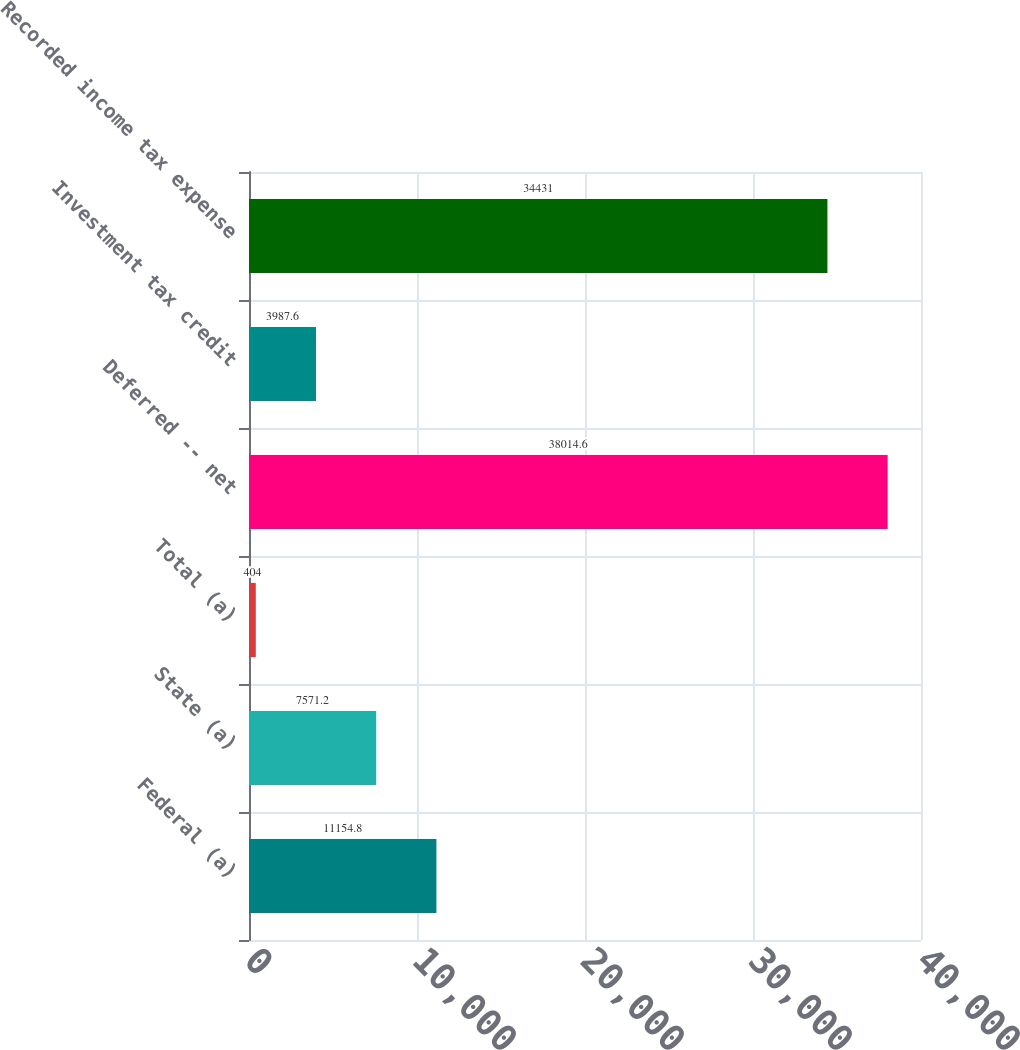<chart> <loc_0><loc_0><loc_500><loc_500><bar_chart><fcel>Federal (a)<fcel>State (a)<fcel>Total (a)<fcel>Deferred -- net<fcel>Investment tax credit<fcel>Recorded income tax expense<nl><fcel>11154.8<fcel>7571.2<fcel>404<fcel>38014.6<fcel>3987.6<fcel>34431<nl></chart> 